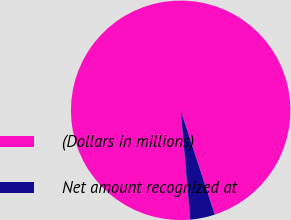Convert chart to OTSL. <chart><loc_0><loc_0><loc_500><loc_500><pie_chart><fcel>(Dollars in millions)<fcel>Net amount recognized at<nl><fcel>96.36%<fcel>3.64%<nl></chart> 